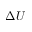<formula> <loc_0><loc_0><loc_500><loc_500>\Delta U</formula> 